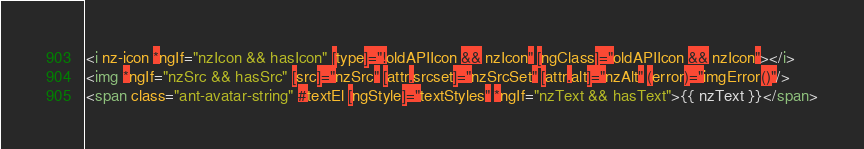Convert code to text. <code><loc_0><loc_0><loc_500><loc_500><_HTML_><i nz-icon *ngIf="nzIcon && hasIcon" [type]="!oldAPIIcon && nzIcon" [ngClass]="oldAPIIcon && nzIcon"></i>
<img *ngIf="nzSrc && hasSrc" [src]="nzSrc" [attr.srcset]="nzSrcSet" [attr.alt]="nzAlt" (error)="imgError()"/>
<span class="ant-avatar-string" #textEl [ngStyle]="textStyles" *ngIf="nzText && hasText">{{ nzText }}</span></code> 